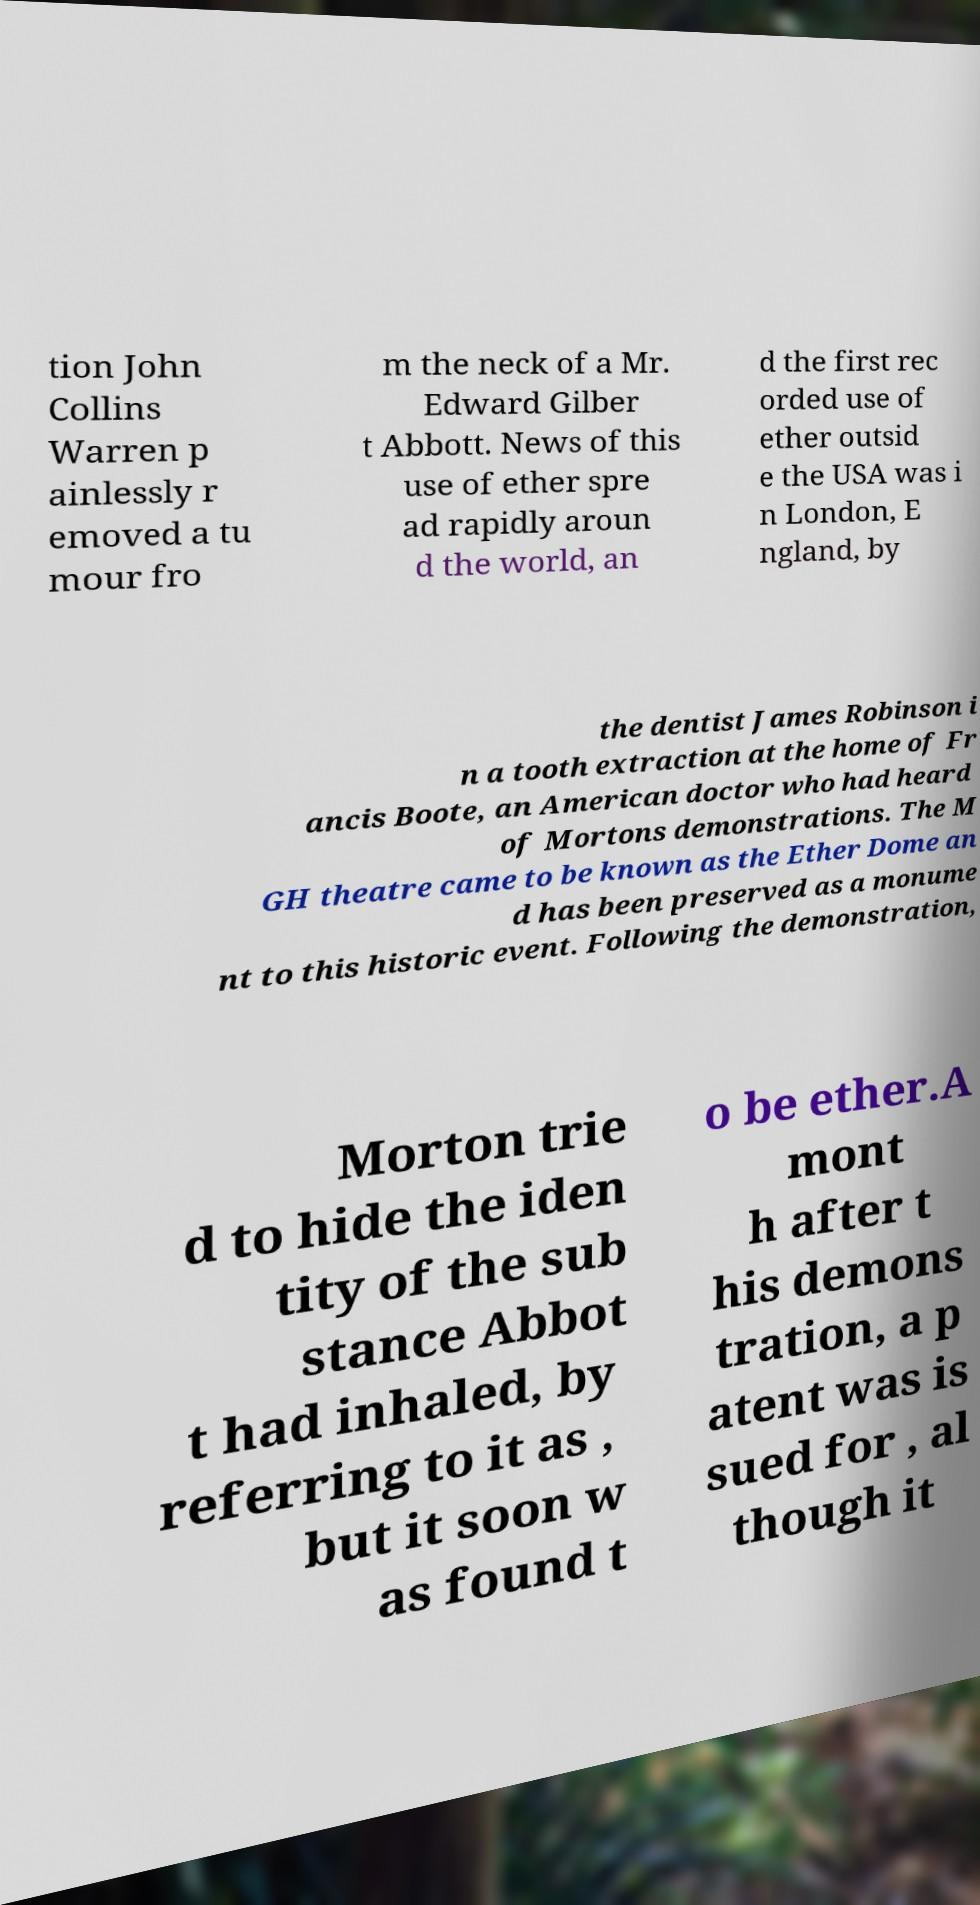What messages or text are displayed in this image? I need them in a readable, typed format. tion John Collins Warren p ainlessly r emoved a tu mour fro m the neck of a Mr. Edward Gilber t Abbott. News of this use of ether spre ad rapidly aroun d the world, an d the first rec orded use of ether outsid e the USA was i n London, E ngland, by the dentist James Robinson i n a tooth extraction at the home of Fr ancis Boote, an American doctor who had heard of Mortons demonstrations. The M GH theatre came to be known as the Ether Dome an d has been preserved as a monume nt to this historic event. Following the demonstration, Morton trie d to hide the iden tity of the sub stance Abbot t had inhaled, by referring to it as , but it soon w as found t o be ether.A mont h after t his demons tration, a p atent was is sued for , al though it 